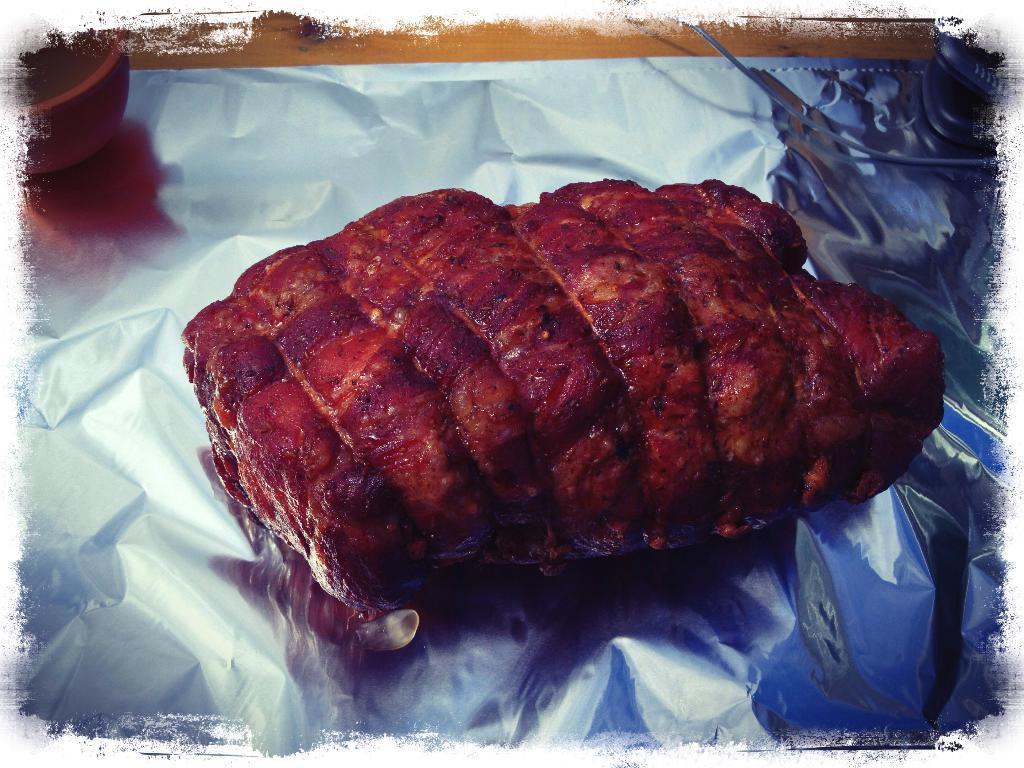How would you summarize this image in a sentence or two? In this image we can see roasted meat on the aluminium foil. 